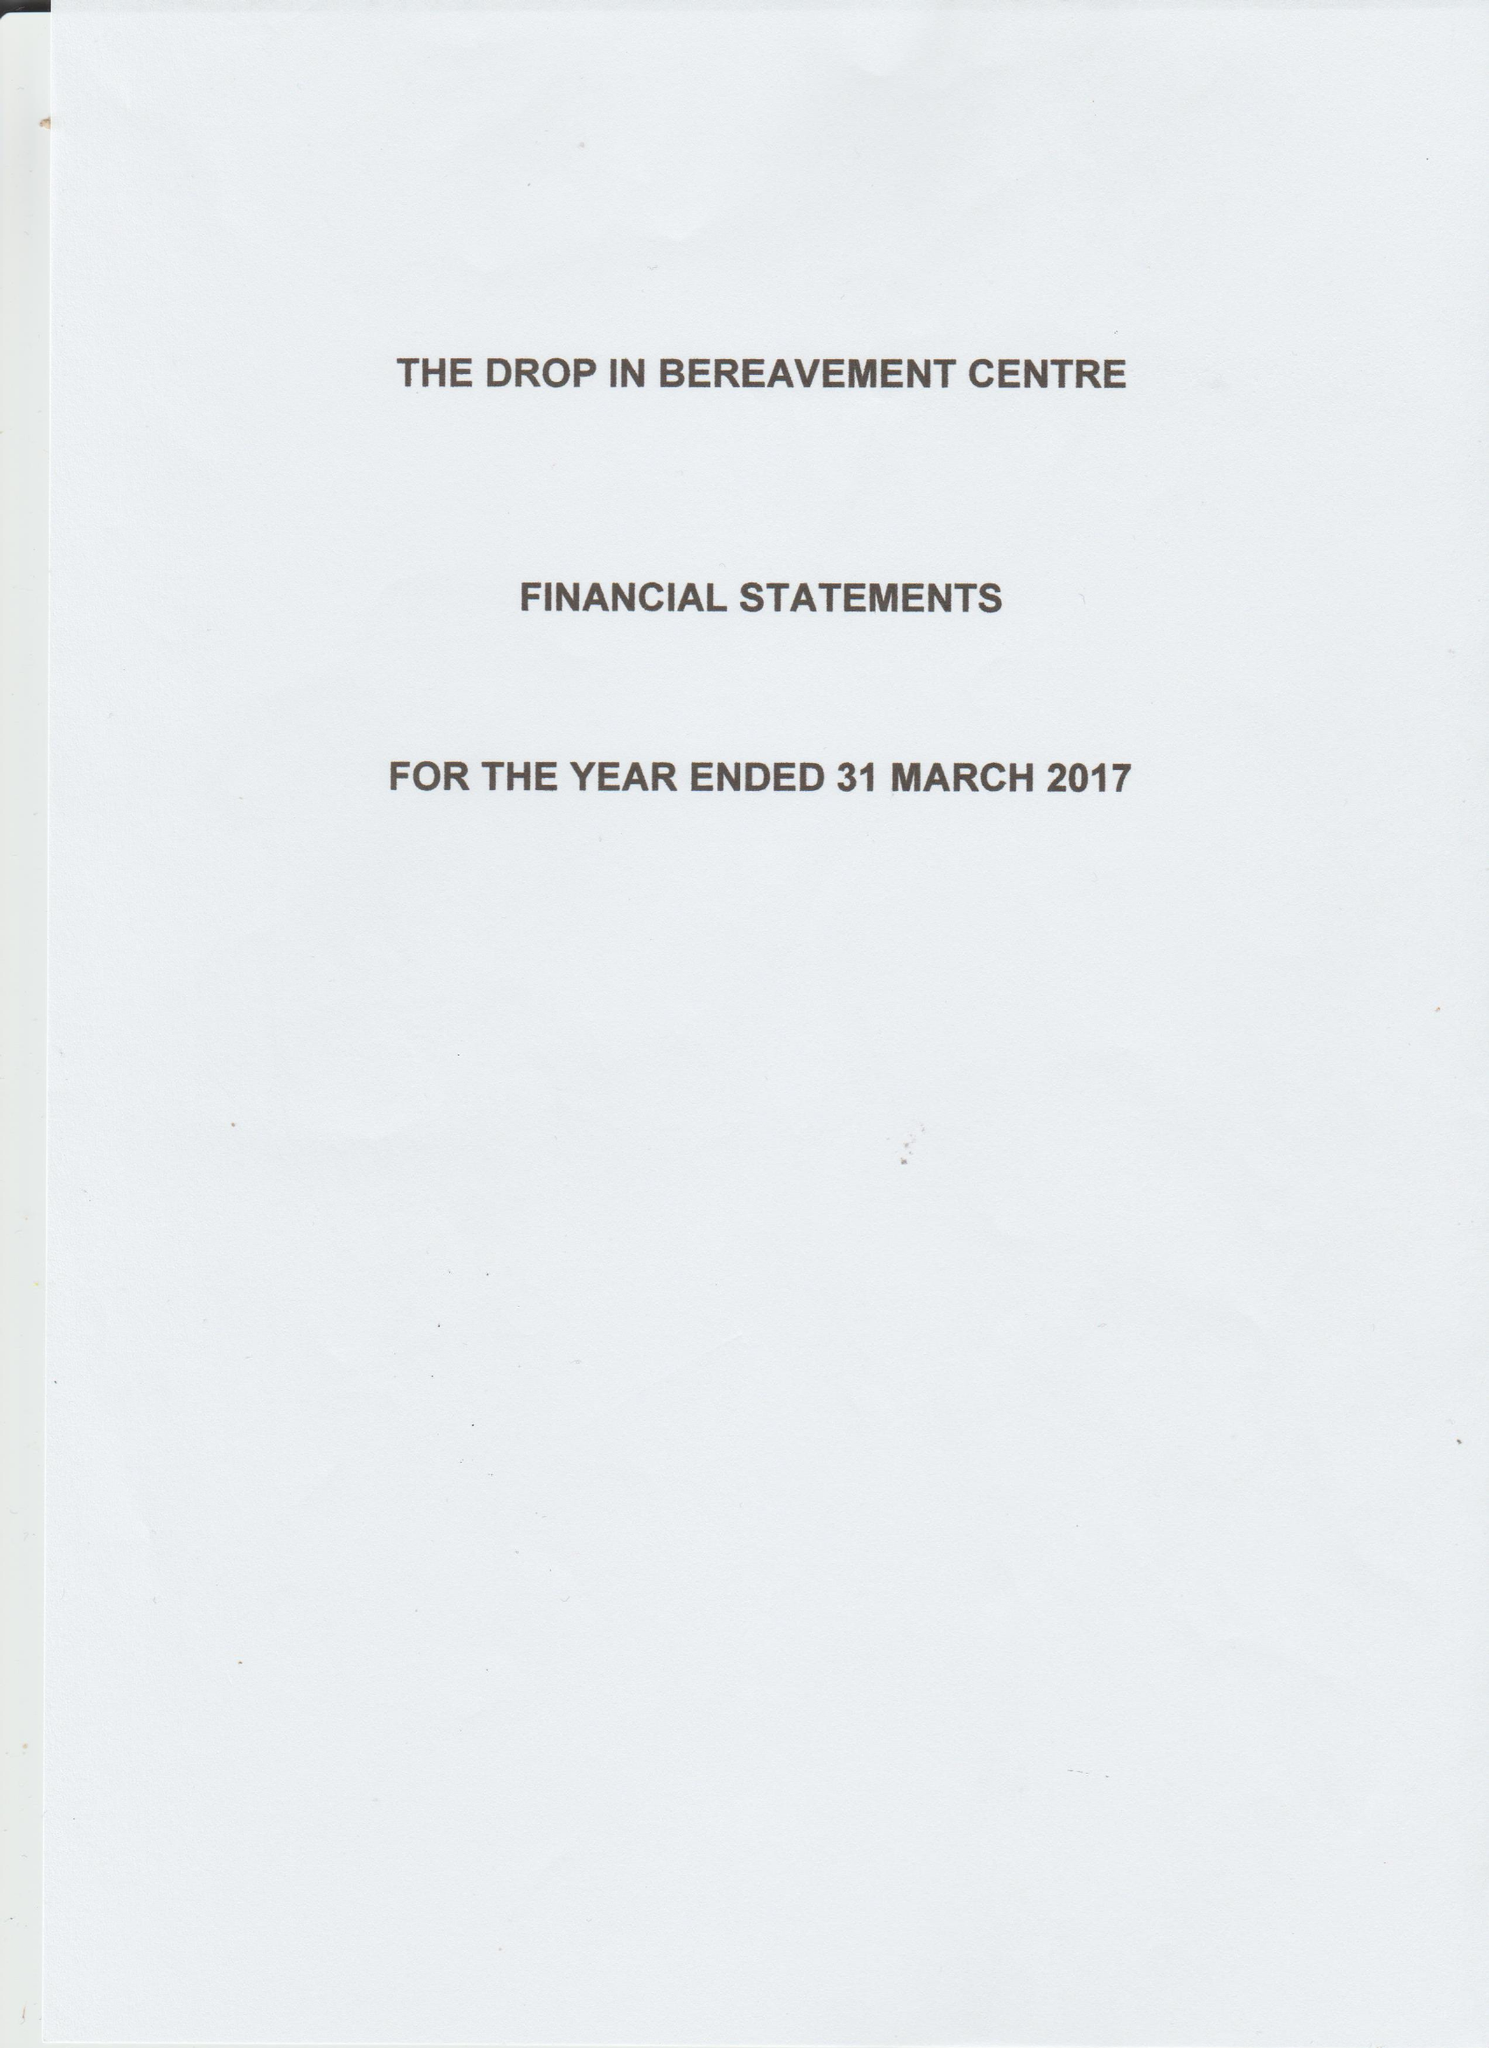What is the value for the income_annually_in_british_pounds?
Answer the question using a single word or phrase. 34925.47 